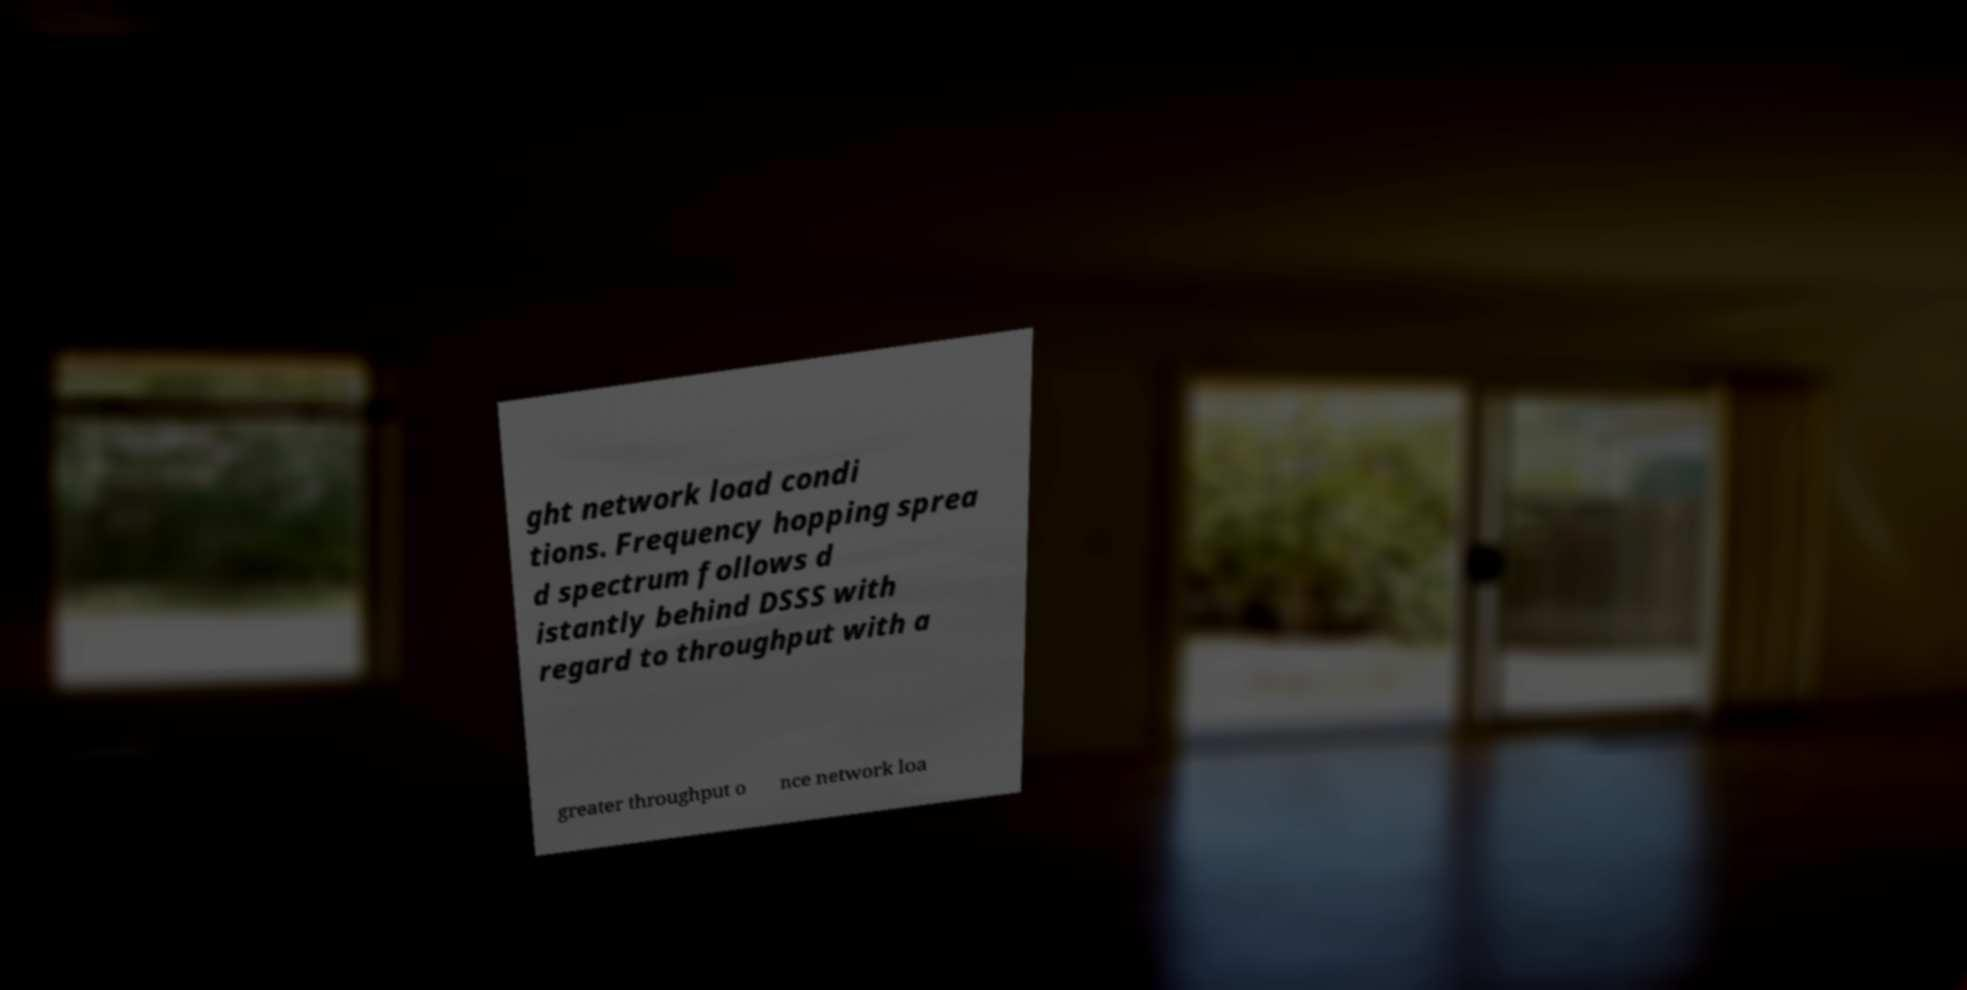Could you extract and type out the text from this image? ght network load condi tions. Frequency hopping sprea d spectrum follows d istantly behind DSSS with regard to throughput with a greater throughput o nce network loa 